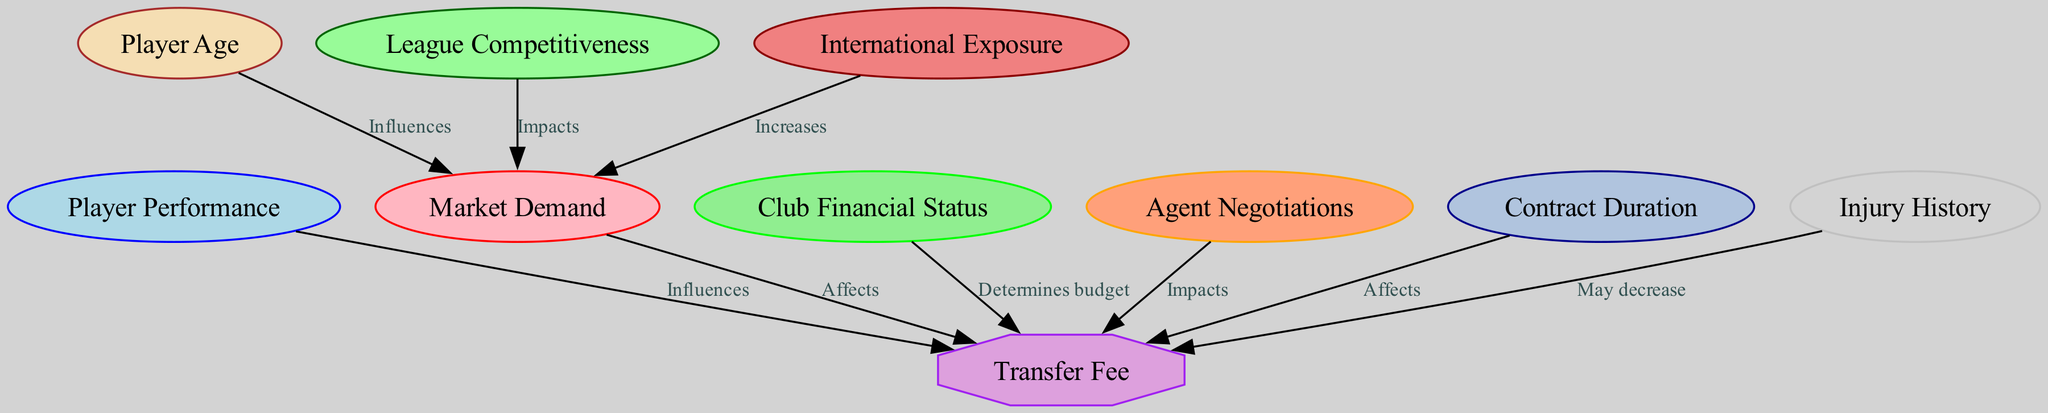What influences the transfer fee? The transfer fee is influenced by several factors, notably player performance, market demand, club financial status, agent negotiations, contract duration, and injury history. Each of these nodes points to the transfer fee node, indicating their direct effect.
Answer: Player performance How many nodes are in the diagram? To determine the number of nodes, we count each distinct factor represented in the graph. There are ten different nodes listed in the data.
Answer: Ten Which node determines the budget for the transfer fee? The club financial status node directly influences the transfer fee by determining the budget, as indicated in the graph. It has a direct edge leading to the transfer fee.
Answer: Club financial status Which factors may decrease the transfer fee? The factors indicated as potentially decreasing the transfer fee include injury history. It has a specific edge associated with a negative impact on the transfer fee.
Answer: Injury history What impact does international exposure have on market demand? International exposure increases market demand according to the graph. It shows a directed edge pointing to market demand which signifies a positive effect.
Answer: Increases How does player age influence market demand? Player age influences market demand as indicated in the graph. There is a direct edge that shows this relationship, suggesting that as player age changes, market demand will also be affected.
Answer: Influences Which node has the most incoming edges? Upon reviewing the graph, the transfer fee node has the most incoming edges from six different nodes. This shows many factors affecting the transfer fee.
Answer: Transfer fee What does the league competitiveness node impact? The league competitiveness node impacts market demand, as explicitly shown in the directed graph with an edge leading to the market demand node.
Answer: Market demand How does contract duration affect the transfer fee? Contract duration affects the transfer fee directly. There is a directed edge connecting contract duration to transfer fee, indicating it has a measurable influence on the fee.
Answer: Affects 